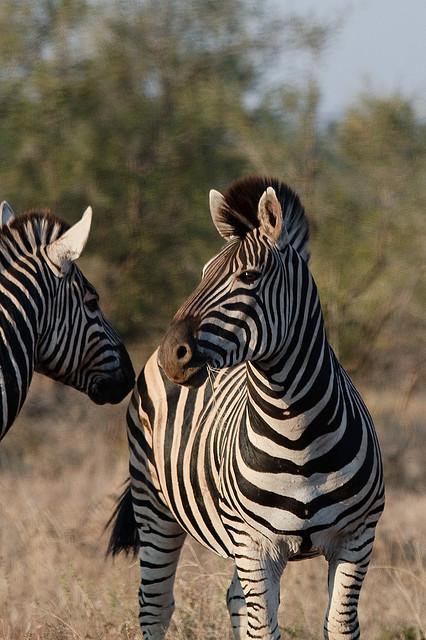How many ears are visible in the photo?
Answer briefly. 4. Are these zebras talking to each other?
Give a very brief answer. No. What is the zebra looking at?
Answer briefly. Zebra. Do these zebras like each other?
Answer briefly. Yes. Could this be in the wild?
Answer briefly. Yes. Are there stripes that don't connect on the neck?
Keep it brief. Yes. 